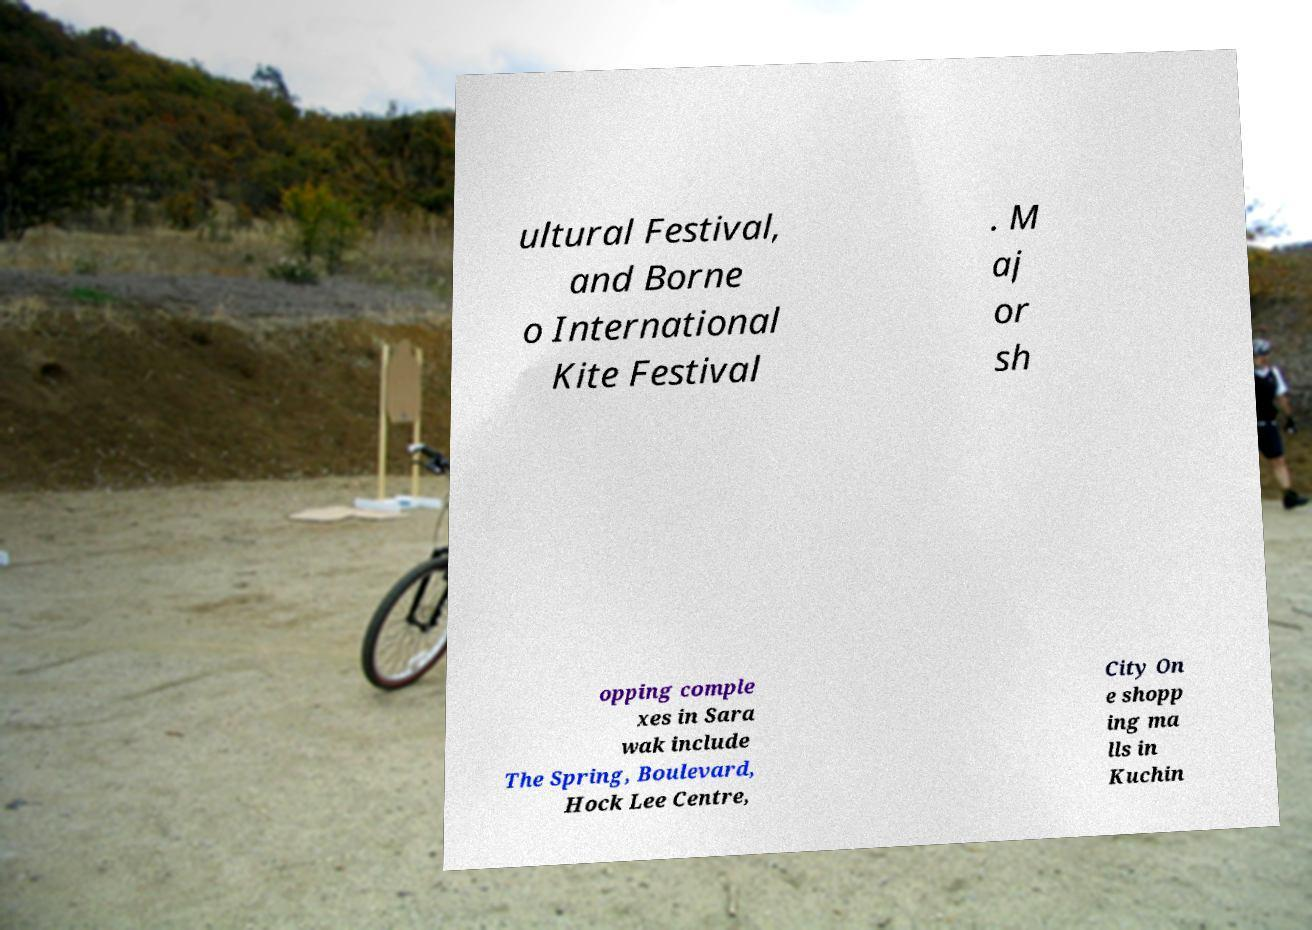I need the written content from this picture converted into text. Can you do that? ultural Festival, and Borne o International Kite Festival . M aj or sh opping comple xes in Sara wak include The Spring, Boulevard, Hock Lee Centre, City On e shopp ing ma lls in Kuchin 